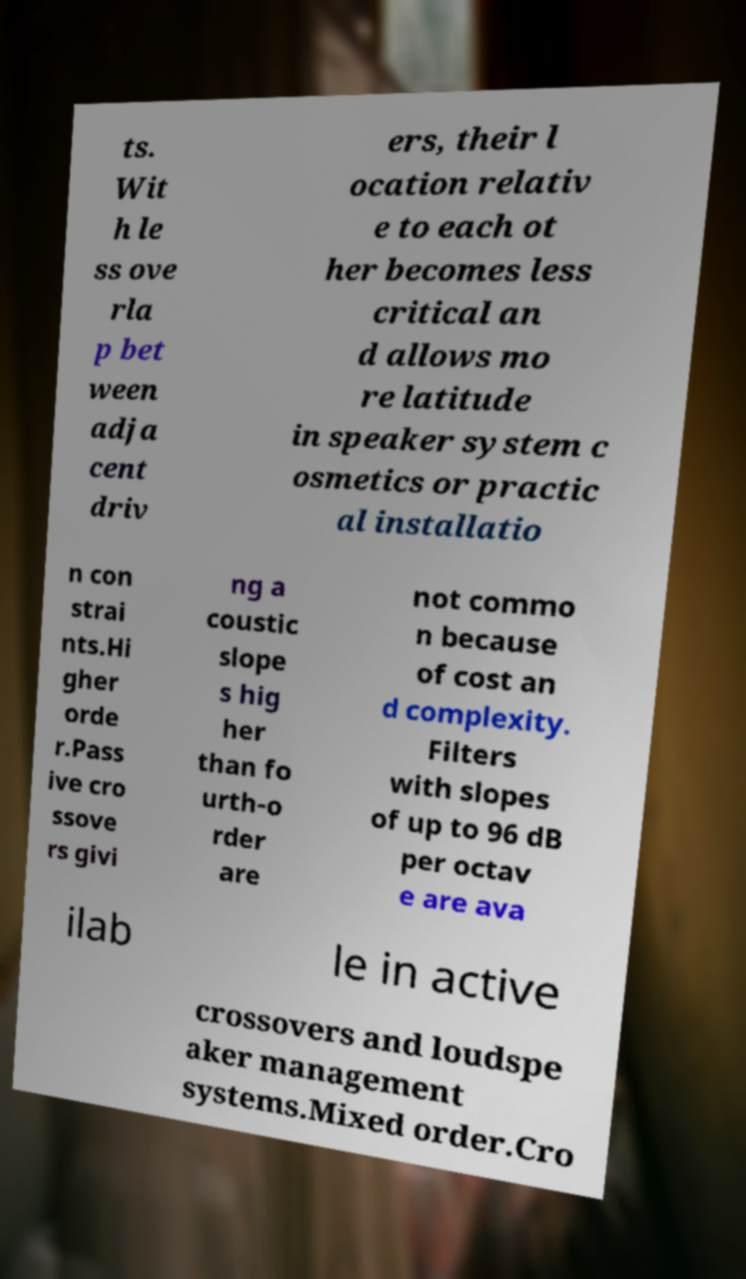Could you extract and type out the text from this image? ts. Wit h le ss ove rla p bet ween adja cent driv ers, their l ocation relativ e to each ot her becomes less critical an d allows mo re latitude in speaker system c osmetics or practic al installatio n con strai nts.Hi gher orde r.Pass ive cro ssove rs givi ng a coustic slope s hig her than fo urth-o rder are not commo n because of cost an d complexity. Filters with slopes of up to 96 dB per octav e are ava ilab le in active crossovers and loudspe aker management systems.Mixed order.Cro 